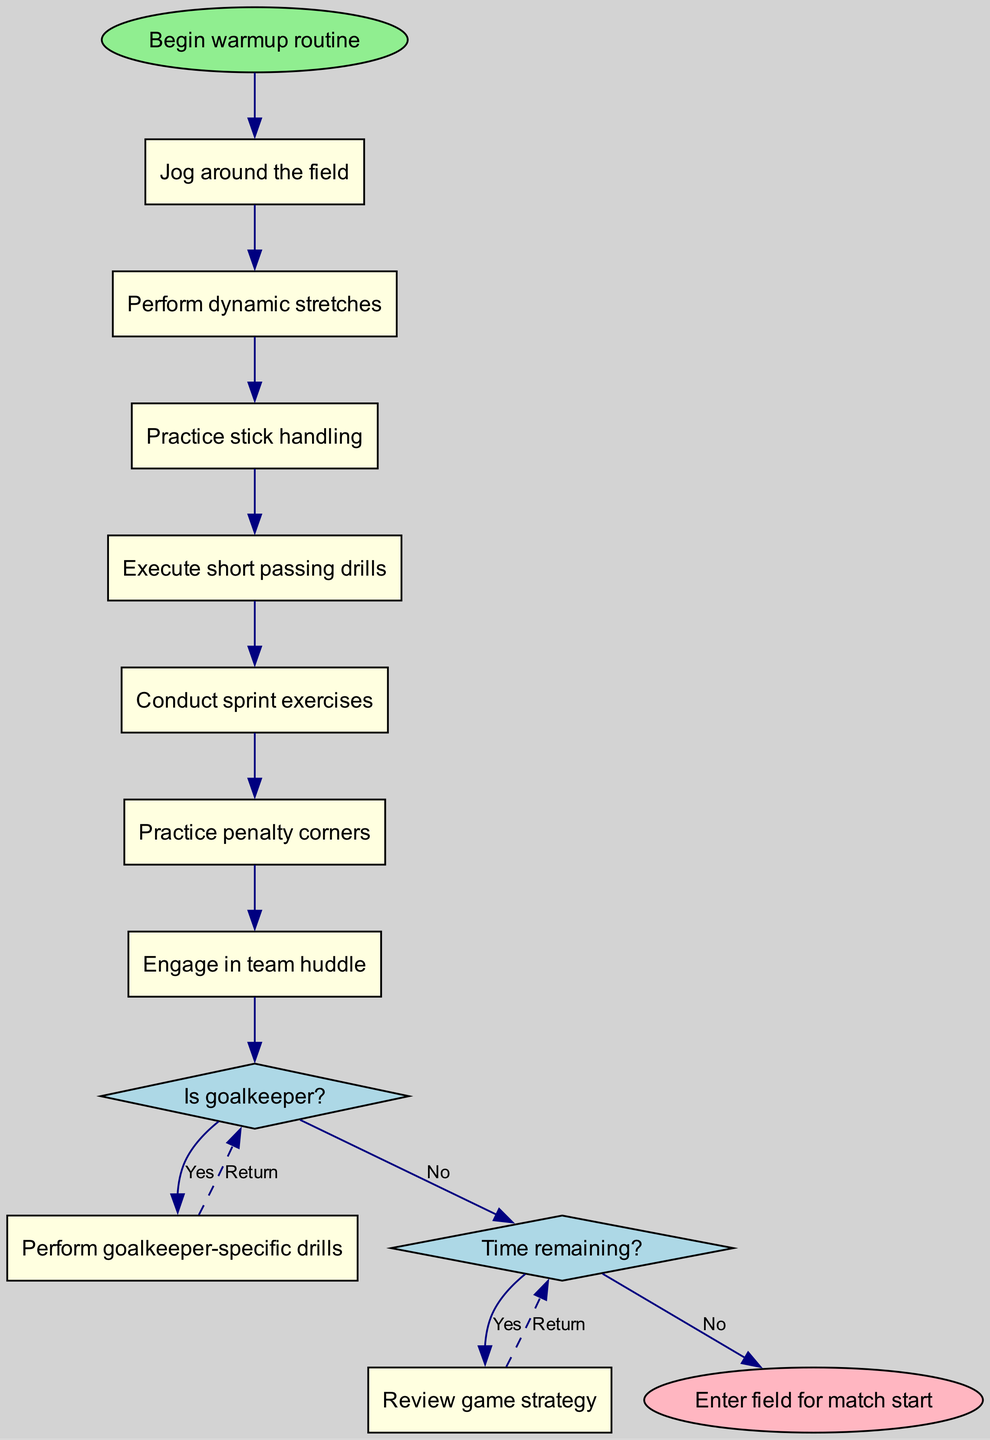What is the starting point of the warmup routine? The starting point is labeled as "Begin warmup routine," which is the first node in the diagram.
Answer: Begin warmup routine How many activities are listed in the warmup routine? There are six activities detailed in the diagram, which are outlined step-by-step after the starting node.
Answer: 6 What is the first activity that Lisa Nolte performs? The first activity is explicitly stated as "Jog around the field," which is connected directly from the starting point.
Answer: Jog around the field What is the decision point that follows the last activity? The diagram includes a decision point asking "Is goalkeeper?" immediately after the last activity "Practice penalty corners," representing a critical choice in the warmup process.
Answer: Is goalkeeper? What happens if the answer to the decision "Is goalkeeper?" is yes? If the answer is yes, the routine includes performing "Perform goalkeeper-specific drills," as indicated in the diagram, which branches from the decision point.
Answer: Perform goalkeeper-specific drills How many decision points are in the warmup routine? The diagram illustrates two decision points, which are clearly defined with their respective conditions and branches in the flow.
Answer: 2 What does Lisa Nolte do if there is time remaining? If there is time remaining, the flow indicates she will "Review game strategy," linking from the decision about time remaining.
Answer: Review game strategy Where does the routine lead after the final preparation? After the final preparation, the routine concludes with entering the field for match start, which is shown as the end node in the diagram.
Answer: Enter field for match start What color represents the end node in the diagram? The end node, designated as "Enter field for match start," is colored light pink as specified within the diagram attributes.
Answer: Light pink 